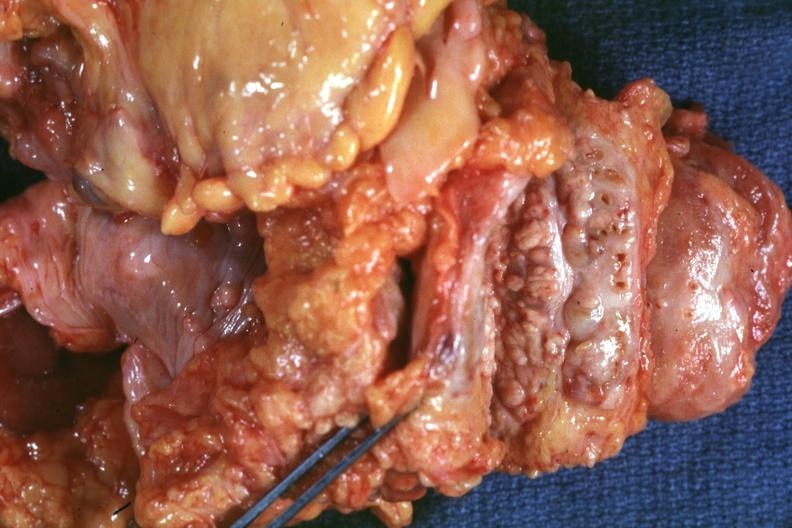s bread-loaf slices into prostate gland photographed close-up showing nodular parenchyma and dense intervening tumor tissue very good?
Answer the question using a single word or phrase. Yes 